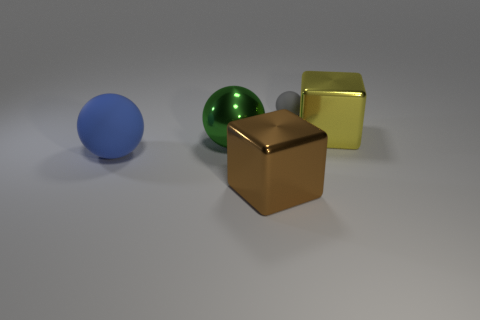Add 3 big brown matte cubes. How many objects exist? 8 Subtract all blocks. How many objects are left? 3 Subtract all large blue matte spheres. Subtract all large rubber balls. How many objects are left? 3 Add 1 tiny matte spheres. How many tiny matte spheres are left? 2 Add 5 green things. How many green things exist? 6 Subtract 0 yellow cylinders. How many objects are left? 5 